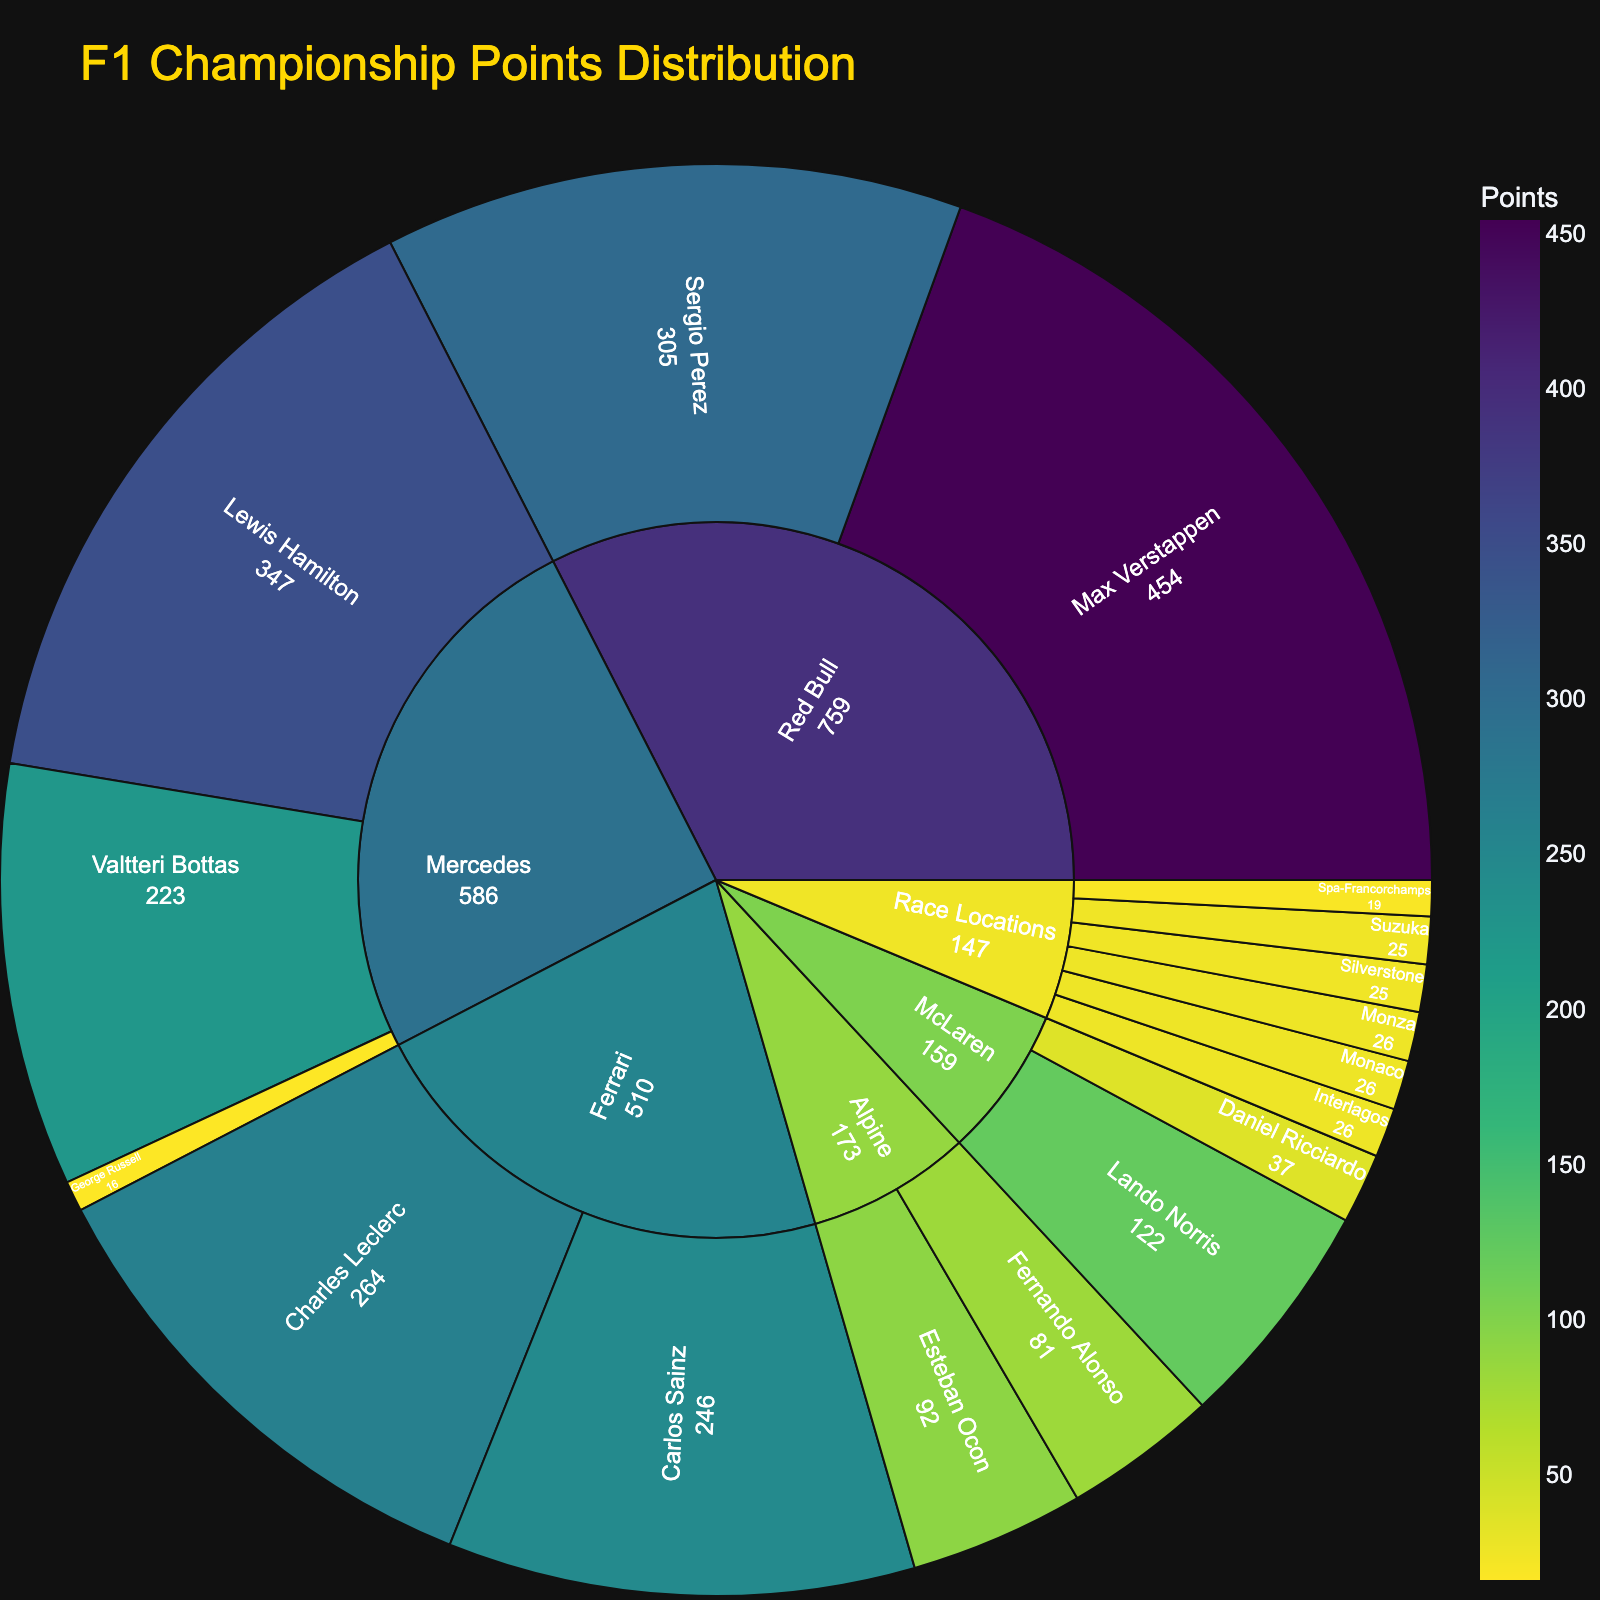Which driver from Mercedes has the highest points? Look at the subcategories under the Mercedes section. Lewis Hamilton has the highest value among the Mercedes drivers.
Answer: Lewis Hamilton What's the combined points total for Ferrari drivers? Sum the points for Charles Leclerc and Carlos Sainz under Ferrari. 264 (Leclerc) + 246 (Sainz) = 510 points.
Answer: 510 How many race locations have points? Count the number of subcategories under the Race Locations category. There are 6 locations listed.
Answer: 6 Who has more points, Max Verstappen or Sergio Perez? Compare the values for Max Verstappen and Sergio Perez under the Red Bull section. Max Verstappen has 454 points, while Sergio Perez has 305 points.
Answer: Max Verstappen Which Mercedes driver has the lowest points? Check the values for the Mercedes drivers. George Russell has the lowest points with 16.
Answer: George Russell What's the average points for McLaren drivers? Find the points for Lando Norris and Daniel Ricciardo under McLaren. Calculate the average: (122 + 37) / 2 = 79.5.
Answer: 79.5 Compare the total points of Red Bull drivers to the total points of Alpine drivers. Which team's drivers have more points and by how much? Sum the points for Red Bull drivers and Alpine drivers. Red Bull: 454 (Max Verstappen) + 305 (Sergio Perez) = 759. Alpine: 81 (Fernando Alonso) + 92 (Esteban Ocon) = 173. Difference: 759 - 173 = 586.
Answer: Red Bull by 586 Which race location has the highest points? Look at the subcategories under Race Locations. Monza and Interlagos both have the highest points of 26 each.
Answer: Monza and Interlagos What's the difference in points between Lewis Hamilton and Charles Leclerc? Compare the values for Lewis Hamilton and Charles Leclerc. 347 (Hamilton) - 264 (Leclerc) = 83.
Answer: 83 